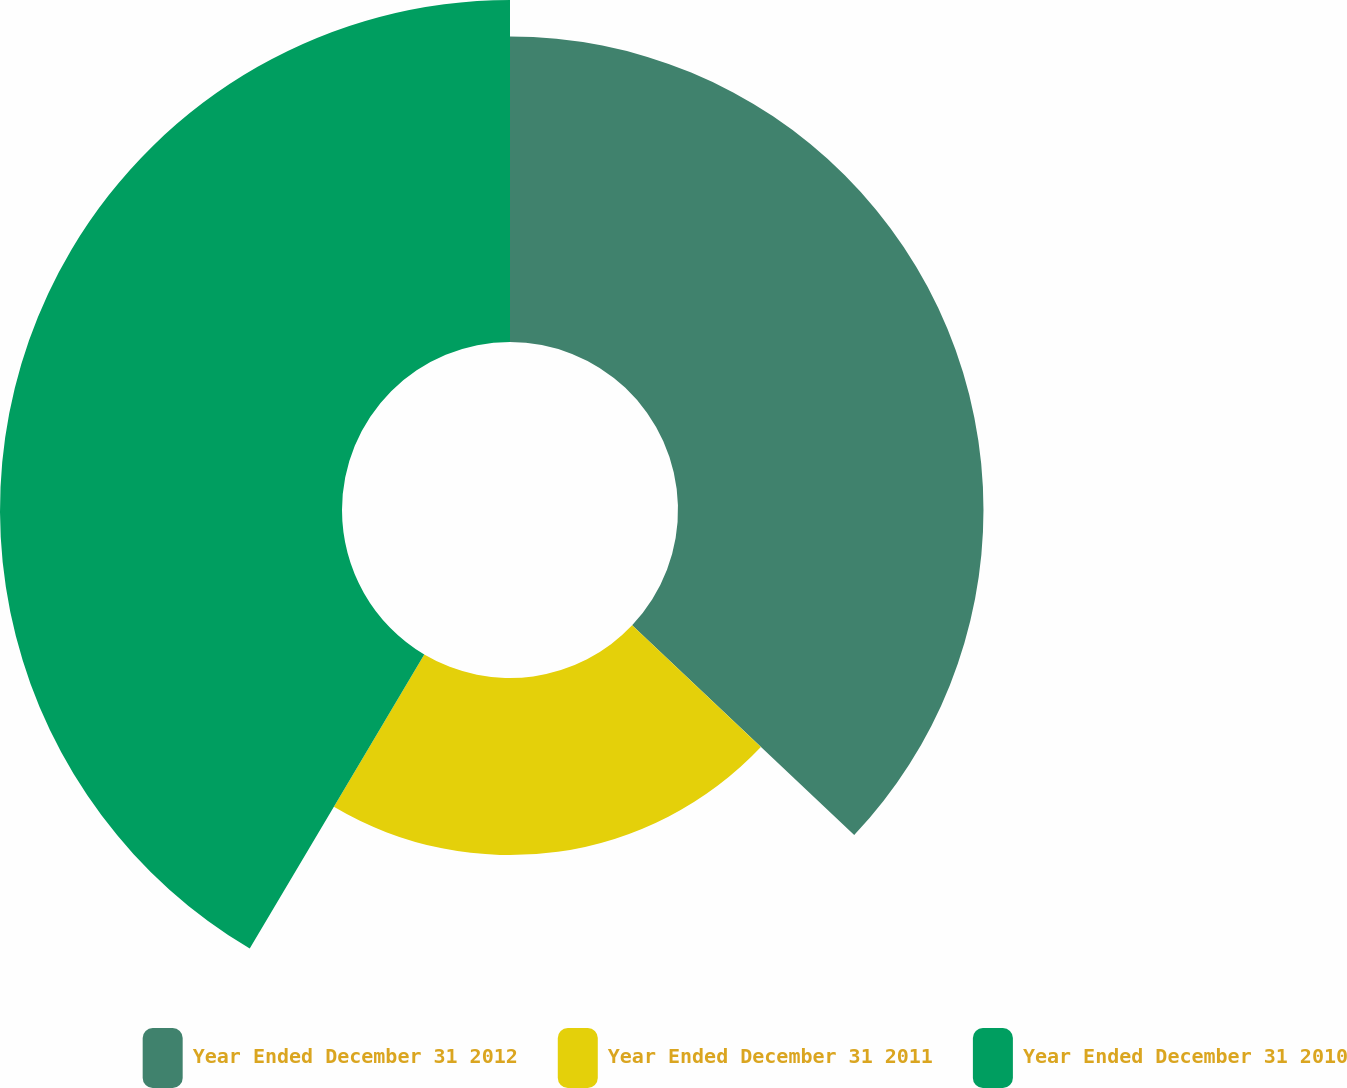Convert chart to OTSL. <chart><loc_0><loc_0><loc_500><loc_500><pie_chart><fcel>Year Ended December 31 2012<fcel>Year Ended December 31 2011<fcel>Year Ended December 31 2010<nl><fcel>37.05%<fcel>21.48%<fcel>41.48%<nl></chart> 